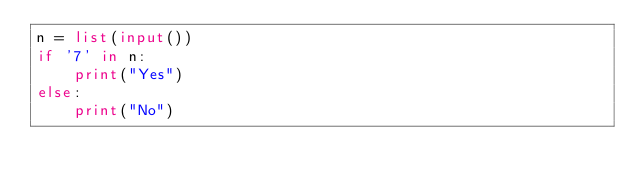<code> <loc_0><loc_0><loc_500><loc_500><_Python_>n = list(input())
if '7' in n:
    print("Yes")
else:
    print("No")</code> 